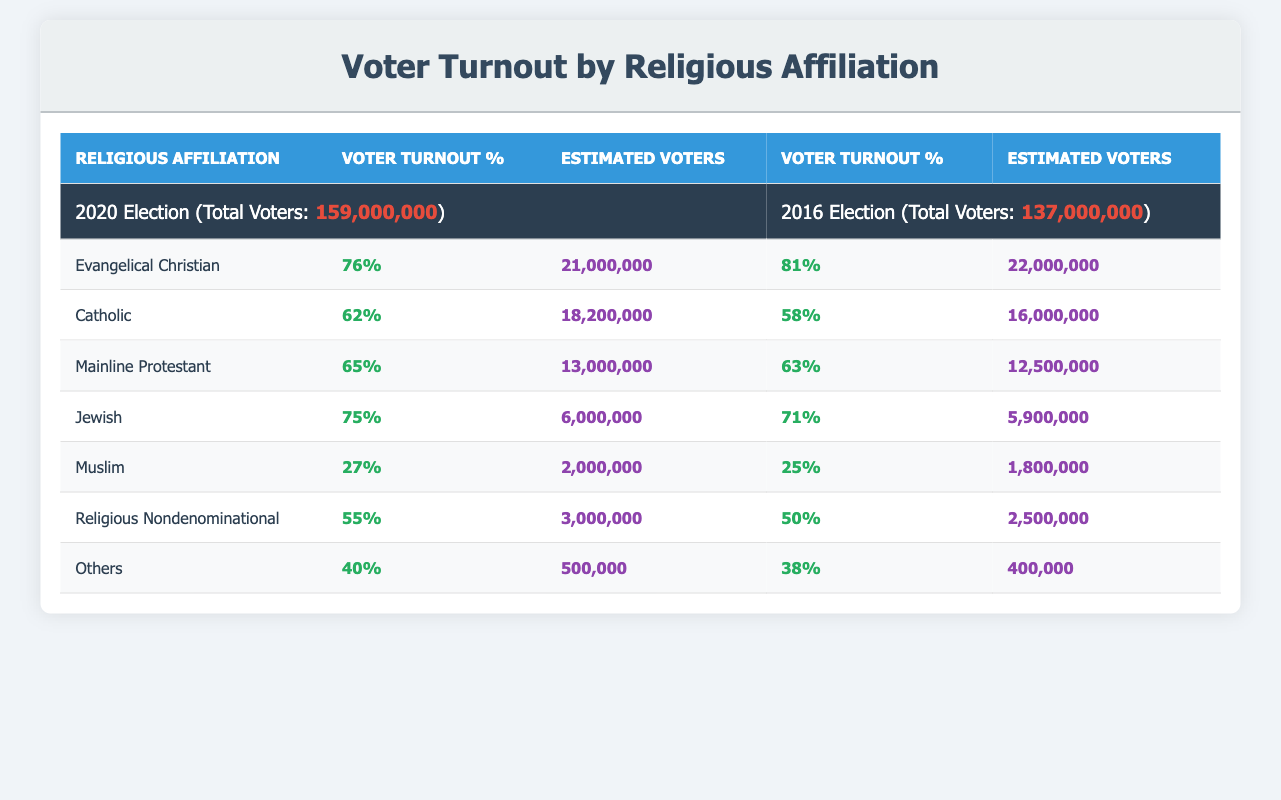What was the voter turnout percentage for Evangelical Christians in the 2020 election? The data shows that Evangelical Christians had a voter turnout percentage of 76% in the 2020 election, which can be found in the corresponding row under the "2020 Election" section.
Answer: 76% How many estimated voters were there for Catholics in the 2016 election? Referring to the table, the estimated number of Catholic voters in the 2016 election is found in the row for Catholics under the 2016 Election section. It indicates there were approximately 16,000,000 Catholics.
Answer: 16,000,000 What is the difference in voter turnout percentage for Jewish voters between the 2020 and 2016 elections? From the table, the voter turnout for Jewish voters was 75% in 2020 and 71% in 2016. The difference can be calculated as 75% - 71% = 4%.
Answer: 4% Did the voter turnout for Muslim voters increase or decrease from 2016 to 2020? The turnout for Muslim voters was 25% in 2016 and increased to 27% in 2020 as per the data in the table. Since 27% is higher than 25%, the turnout increased.
Answer: Yes Which religious group had the highest estimated voters in the 2020 election? Looking at the table, Evangelical Christians have the highest estimated voters at 21,000,000 in the 2020 election. This can be confirmed by comparing all estimated voter figures across different religious affiliations in that column.
Answer: Evangelical Christians What is the average voter turnout percentage across all religious affiliations listed for the 2020 election? To find the average, add the voter turnout percentages for all groups in 2020: 76 + 62 + 65 + 75 + 27 + 55 + 40 = 400. Then, divide by the number of groups, which is 7. Thus, the average is 400 / 7 = 57.14%.
Answer: Approximately 57.14% What was the estimated number of voters for Mainline Protestants in both elections combined? In the 2020 election, there were approximately 13,000,000 Mainline Protestants and in the 2016 election, there were approximately 12,500,000. To combine these, sum the two: 13,000,000 + 12,500,000 = 25,500,000.
Answer: 25,500,000 Did the voter turnout percentage for Religious Nondenominational groups increase or decrease from 2016 to 2020? Referring to the supplied data, the voter turnout for Religious Nondenominational groups was 50% in 2016 and increased to 55% in 2020. Since 55% is greater than 50%, the turnout percentage increased.
Answer: Increased 